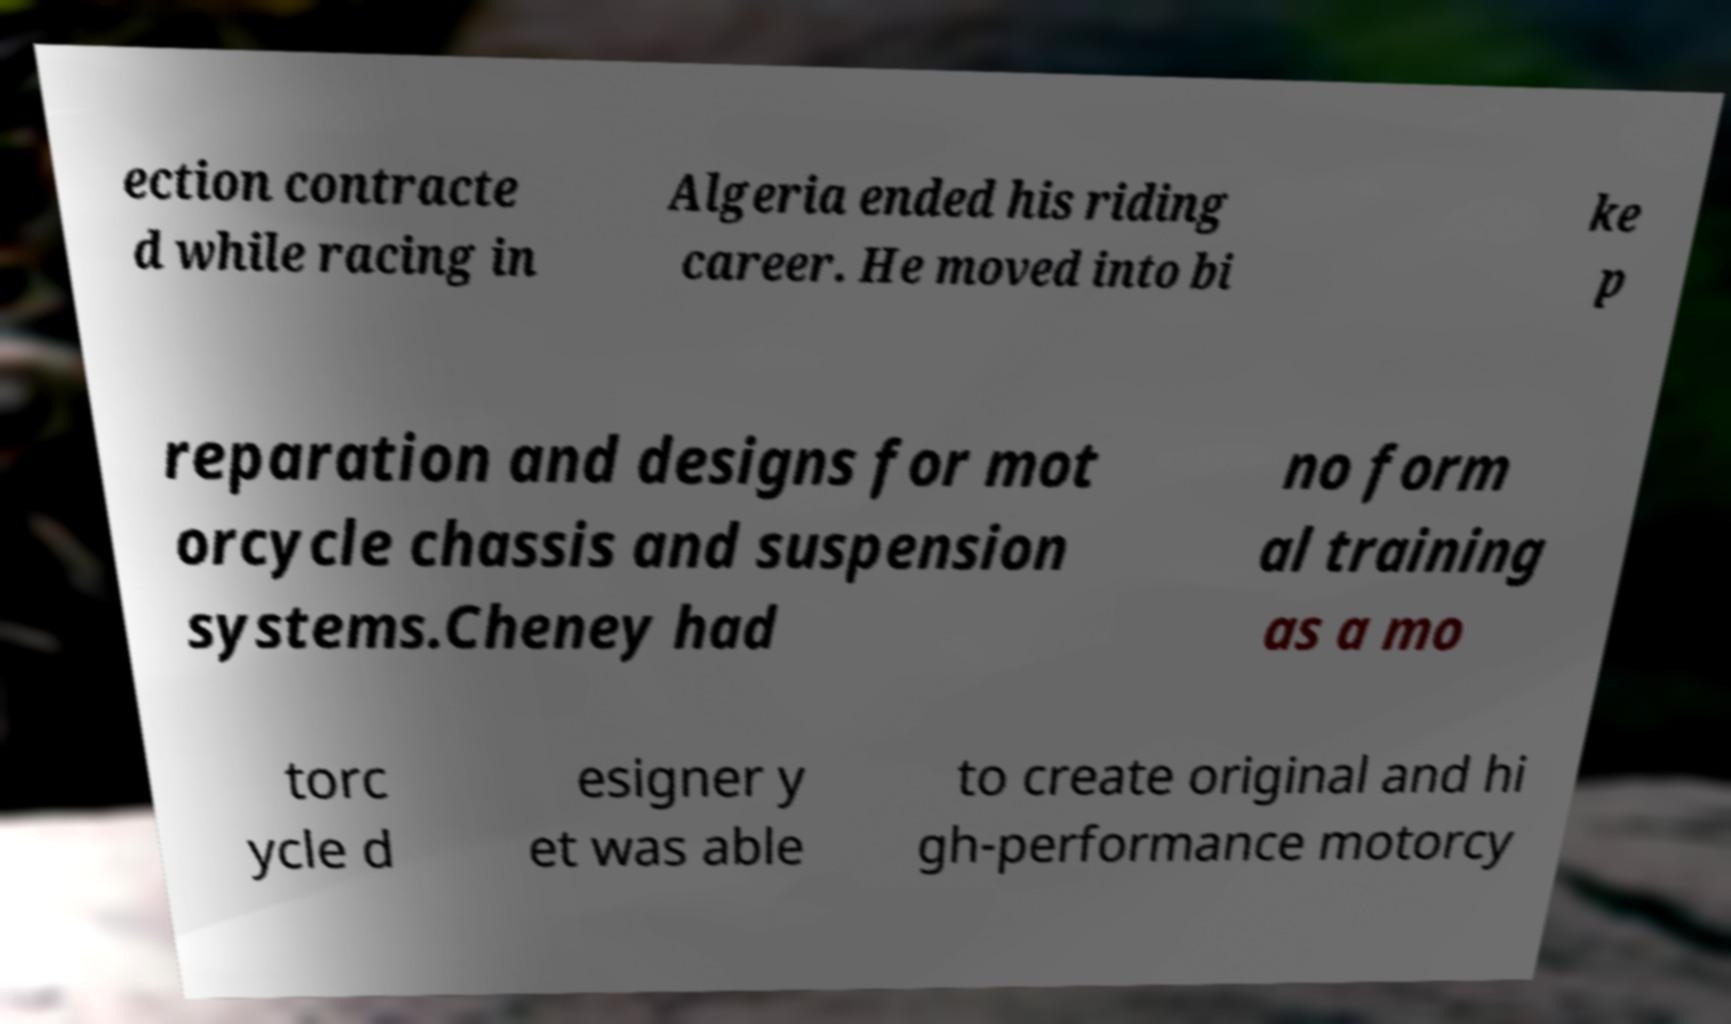Can you read and provide the text displayed in the image?This photo seems to have some interesting text. Can you extract and type it out for me? ection contracte d while racing in Algeria ended his riding career. He moved into bi ke p reparation and designs for mot orcycle chassis and suspension systems.Cheney had no form al training as a mo torc ycle d esigner y et was able to create original and hi gh-performance motorcy 